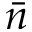<formula> <loc_0><loc_0><loc_500><loc_500>\bar { n }</formula> 